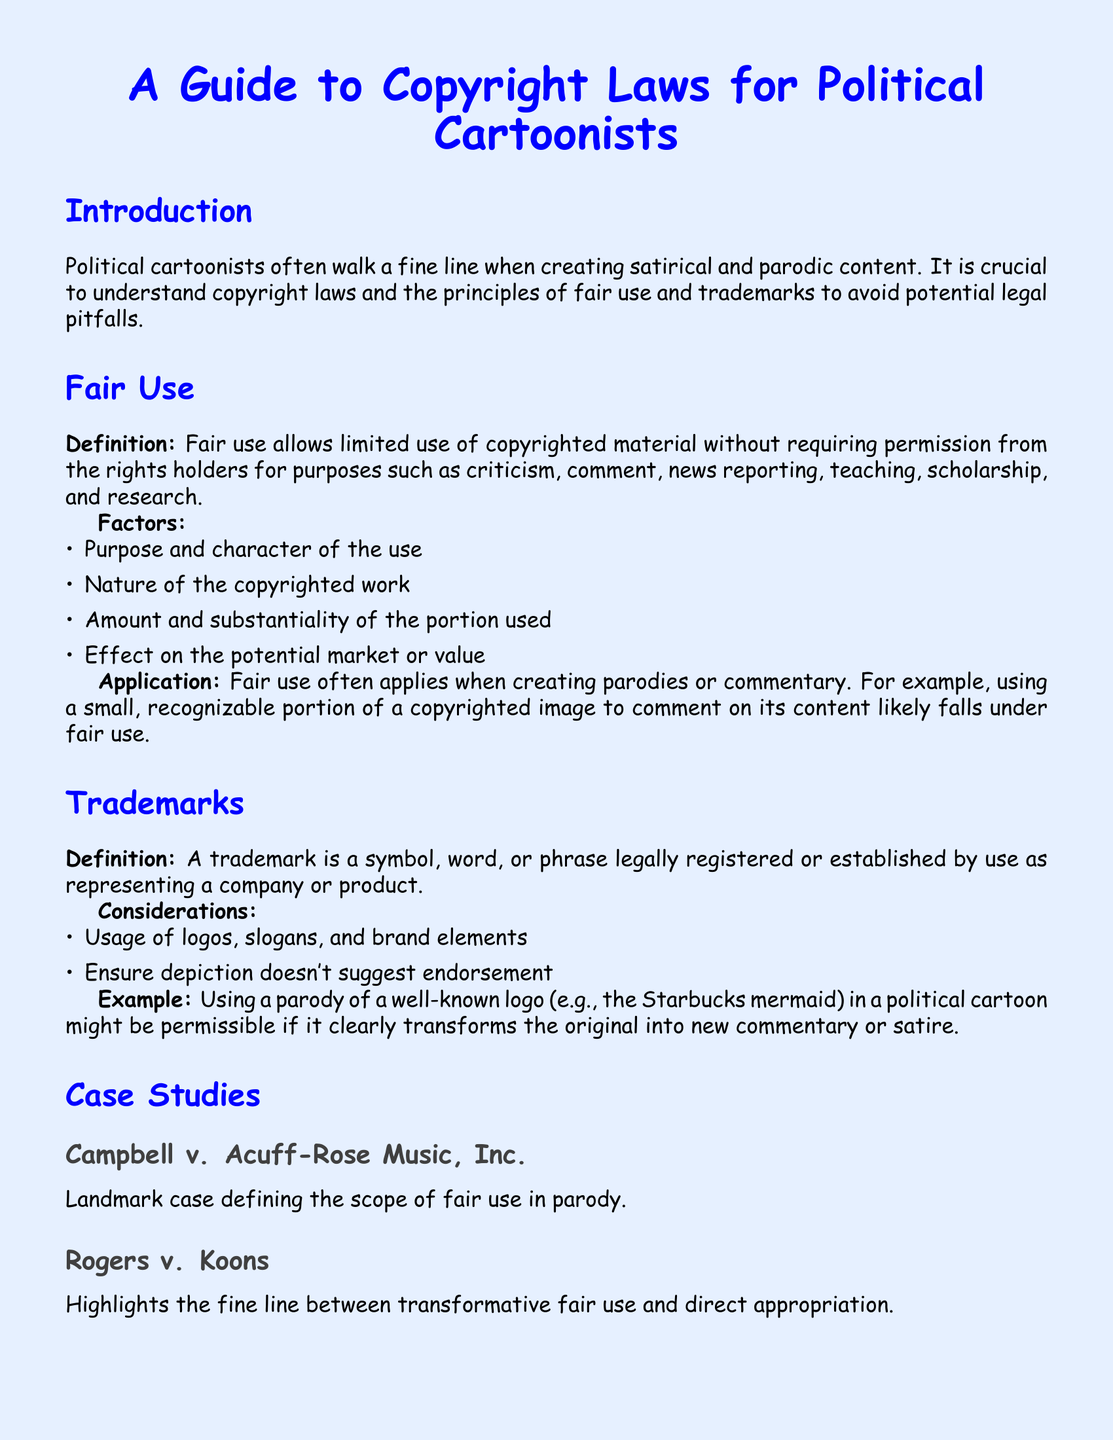What is the title of the document? The title is presented prominently at the top of the document.
Answer: A Guide to Copyright Laws for Political Cartoonists What is the purpose of fair use? The document states that fair use allows limited use of copyrighted material for specific purposes.
Answer: Criticism, comment, news reporting, teaching, scholarship, and research What landmark case is mentioned regarding fair use? A specific case is cited to illustrate the definition of fair use.
Answer: Campbell v. Acuff-Rose Music, Inc What color is used for the main font in the document? The document is formatted with a specific type of font color.
Answer: Blue What should political cartoonists ensure regarding trademarks? The document emphasizes an important consideration for trademark use.
Answer: Ensure depiction doesn't suggest endorsement What are the factors of fair use listed in the document? Factors that determine fair use are detailed in the text.
Answer: Purpose and character, Nature of the copyrighted work, Amount and substantiality, Effect on potential market What is a trademark? The document defines a specific term related to copyright.
Answer: A symbol, word, or phrase legally registered or established What is the example provided for trademark use in a political cartoon? An example is given to illustrate permissible use related to trademarks.
Answer: Parody of a well-known logo (e.g., the Starbucks mermaid) What is the color of the background page? The document describes the overall background color used.
Answer: Light blue 